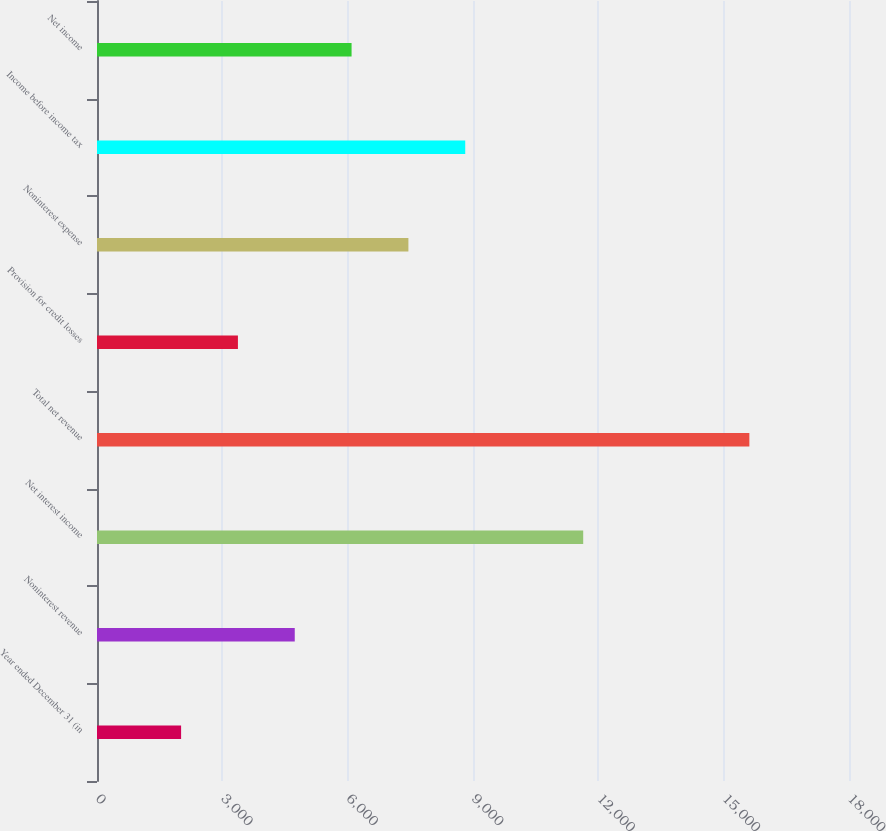<chart> <loc_0><loc_0><loc_500><loc_500><bar_chart><fcel>Year ended December 31 (in<fcel>Noninterest revenue<fcel>Net interest income<fcel>Total net revenue<fcel>Provision for credit losses<fcel>Noninterest expense<fcel>Income before income tax<fcel>Net income<nl><fcel>2013<fcel>4733.4<fcel>11638<fcel>15615<fcel>3373.2<fcel>7453.8<fcel>8814<fcel>6093.6<nl></chart> 